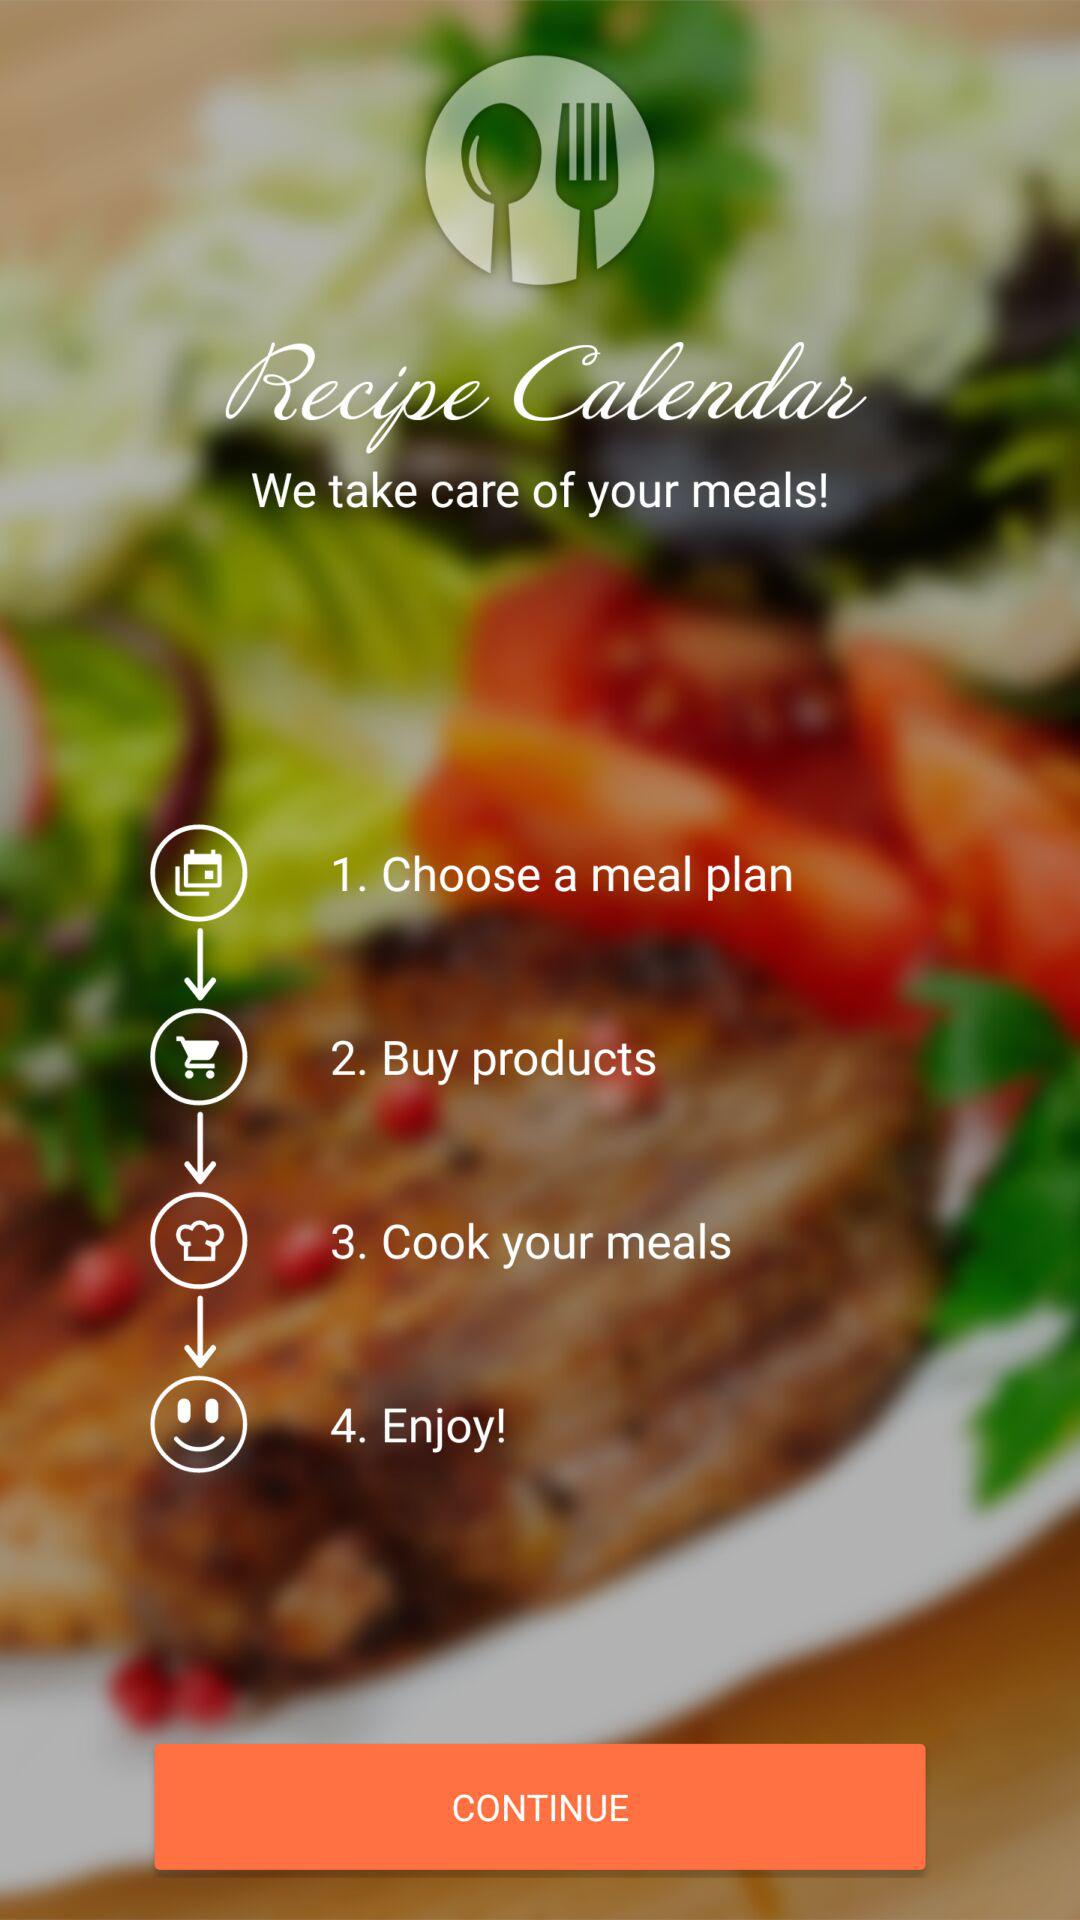What is the name of the application? The name of the application is "Recipe Calendar". 